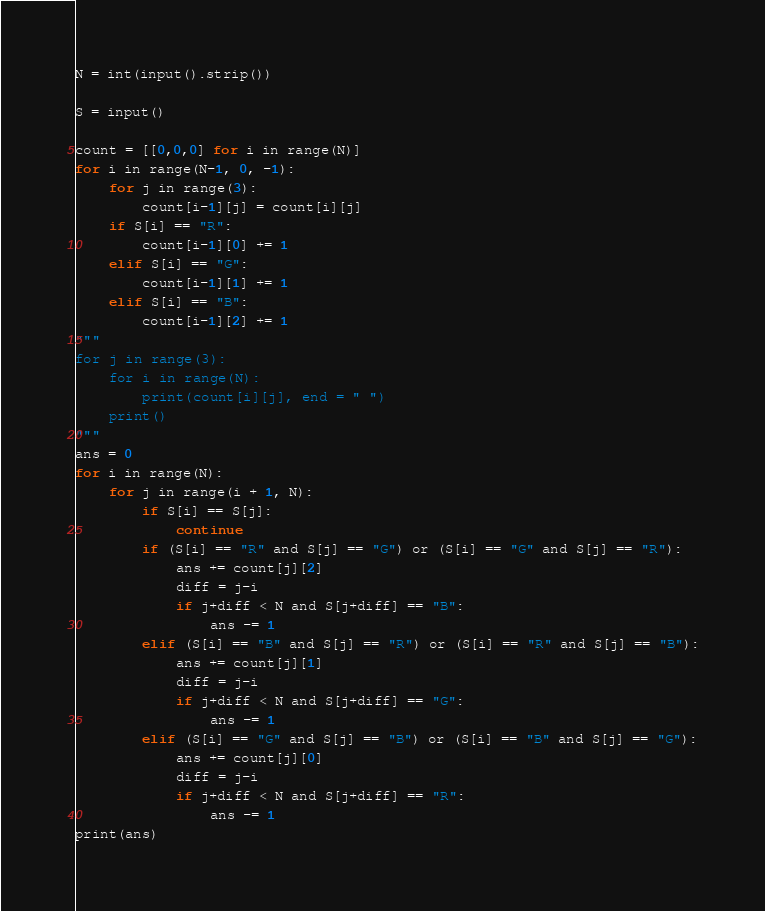<code> <loc_0><loc_0><loc_500><loc_500><_Python_>N = int(input().strip())

S = input()

count = [[0,0,0] for i in range(N)]
for i in range(N-1, 0, -1):
    for j in range(3):
        count[i-1][j] = count[i][j]
    if S[i] == "R":
        count[i-1][0] += 1
    elif S[i] == "G":
        count[i-1][1] += 1
    elif S[i] == "B":
        count[i-1][2] += 1
"""
for j in range(3):
    for i in range(N):
        print(count[i][j], end = " ")
    print()
"""
ans = 0
for i in range(N):
    for j in range(i + 1, N):
        if S[i] == S[j]:
            continue
        if (S[i] == "R" and S[j] == "G") or (S[i] == "G" and S[j] == "R"):
            ans += count[j][2]
            diff = j-i
            if j+diff < N and S[j+diff] == "B":
                ans -= 1
        elif (S[i] == "B" and S[j] == "R") or (S[i] == "R" and S[j] == "B"):
            ans += count[j][1]
            diff = j-i
            if j+diff < N and S[j+diff] == "G":
                ans -= 1
        elif (S[i] == "G" and S[j] == "B") or (S[i] == "B" and S[j] == "G"):
            ans += count[j][0]
            diff = j-i
            if j+diff < N and S[j+diff] == "R":
                ans -= 1
print(ans)</code> 